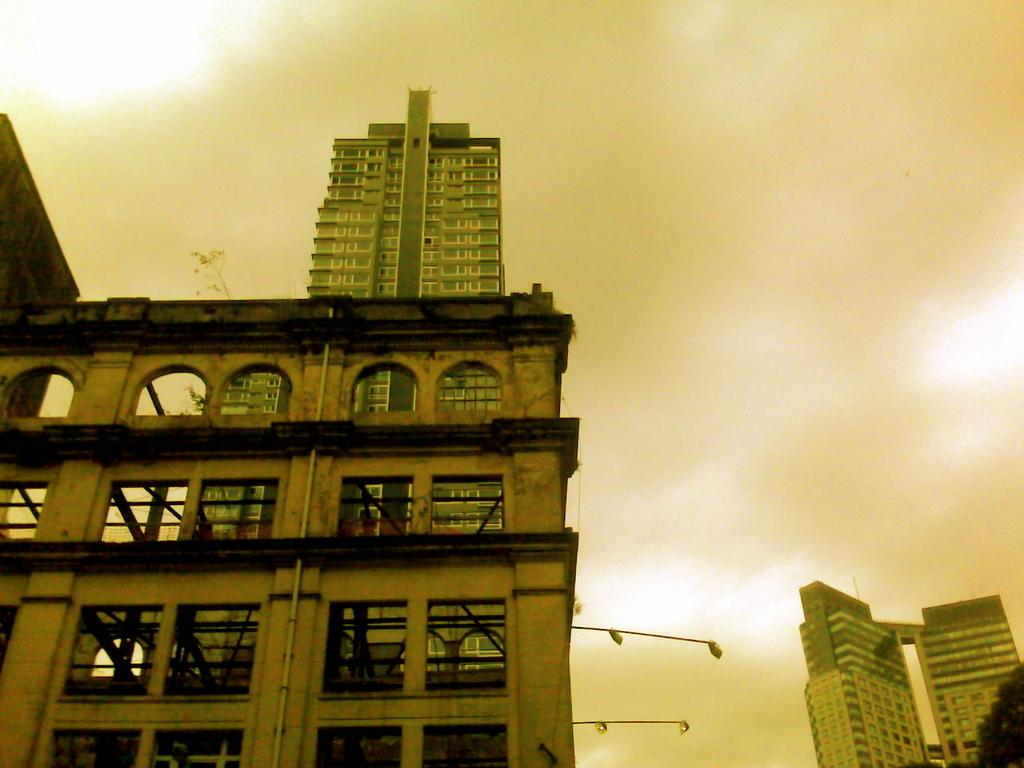What is the color of the building in the image? The building in the image is brown. What type of windows does the building have? The building has many arch design windows. Can you describe the building in the background of the image? There is a big building visible in the background of the image. What type of lace can be seen on the windows of the building in the image? There is no lace visible on the windows of the building in the image; they have arch design windows. 